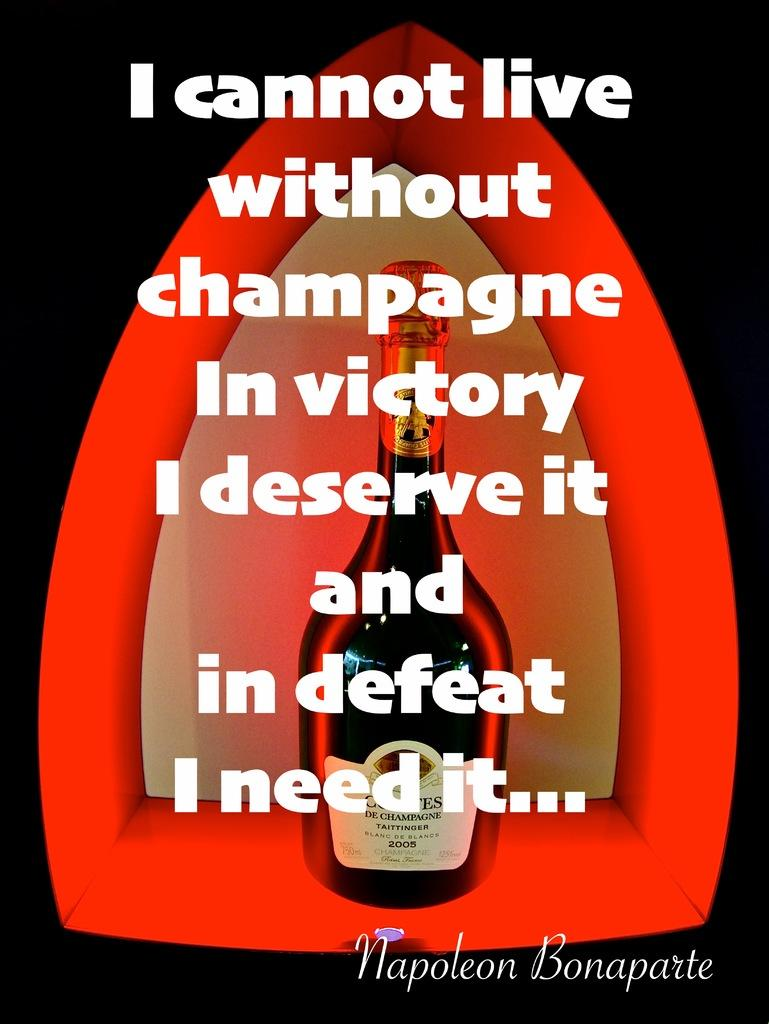<image>
Provide a brief description of the given image. the word champagne is on a little area 